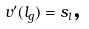<formula> <loc_0><loc_0><loc_500><loc_500>v ^ { \prime } ( l _ { g } ) = s _ { l } \text {,}</formula> 